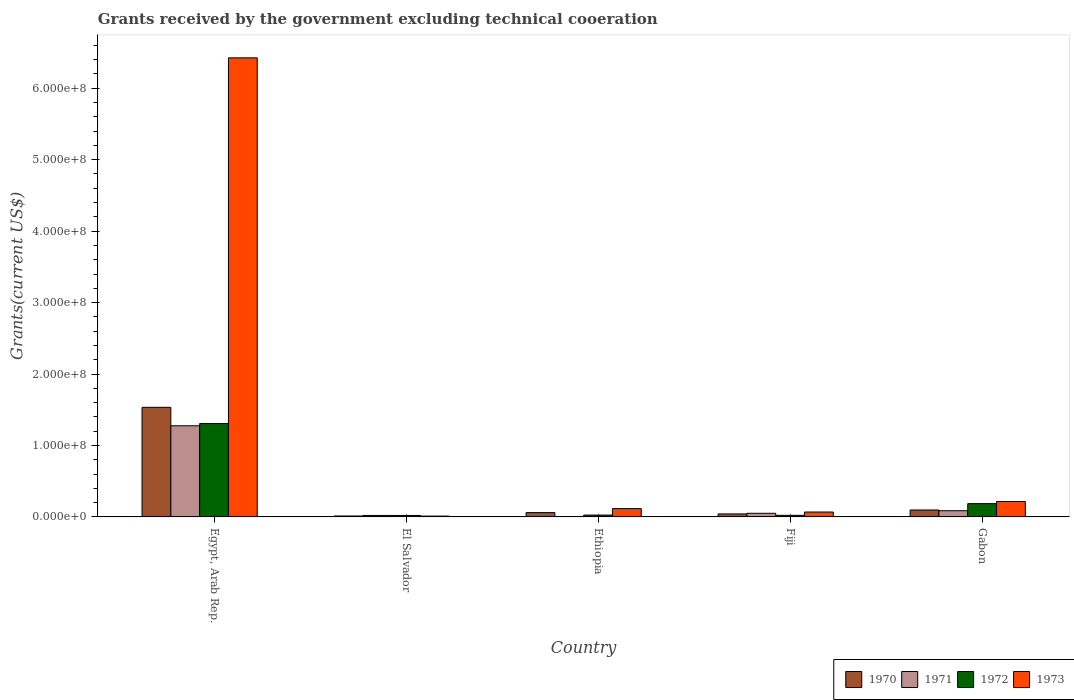How many different coloured bars are there?
Offer a very short reply. 4. How many bars are there on the 1st tick from the left?
Provide a succinct answer. 4. What is the label of the 4th group of bars from the left?
Your answer should be very brief. Fiji. What is the total grants received by the government in 1970 in Fiji?
Ensure brevity in your answer.  4.19e+06. Across all countries, what is the maximum total grants received by the government in 1972?
Keep it short and to the point. 1.31e+08. Across all countries, what is the minimum total grants received by the government in 1972?
Give a very brief answer. 2.07e+06. In which country was the total grants received by the government in 1973 maximum?
Keep it short and to the point. Egypt, Arab Rep. What is the total total grants received by the government in 1971 in the graph?
Your answer should be compact. 1.43e+08. What is the difference between the total grants received by the government in 1973 in Egypt, Arab Rep. and that in El Salvador?
Ensure brevity in your answer.  6.41e+08. What is the difference between the total grants received by the government in 1971 in Egypt, Arab Rep. and the total grants received by the government in 1973 in Fiji?
Provide a short and direct response. 1.21e+08. What is the average total grants received by the government in 1970 per country?
Offer a very short reply. 3.49e+07. What is the difference between the total grants received by the government of/in 1973 and total grants received by the government of/in 1970 in Fiji?
Give a very brief answer. 2.67e+06. In how many countries, is the total grants received by the government in 1971 greater than 500000000 US$?
Offer a terse response. 0. What is the ratio of the total grants received by the government in 1970 in Fiji to that in Gabon?
Offer a very short reply. 0.43. Is the total grants received by the government in 1970 in Ethiopia less than that in Gabon?
Provide a short and direct response. Yes. Is the difference between the total grants received by the government in 1973 in Egypt, Arab Rep. and El Salvador greater than the difference between the total grants received by the government in 1970 in Egypt, Arab Rep. and El Salvador?
Offer a terse response. Yes. What is the difference between the highest and the second highest total grants received by the government in 1971?
Provide a short and direct response. 1.19e+08. What is the difference between the highest and the lowest total grants received by the government in 1973?
Your answer should be compact. 6.41e+08. In how many countries, is the total grants received by the government in 1970 greater than the average total grants received by the government in 1970 taken over all countries?
Give a very brief answer. 1. Is the sum of the total grants received by the government in 1970 in Egypt, Arab Rep. and Gabon greater than the maximum total grants received by the government in 1973 across all countries?
Give a very brief answer. No. Is it the case that in every country, the sum of the total grants received by the government in 1972 and total grants received by the government in 1973 is greater than the sum of total grants received by the government in 1971 and total grants received by the government in 1970?
Provide a succinct answer. No. How many bars are there?
Your response must be concise. 19. Are all the bars in the graph horizontal?
Keep it short and to the point. No. Does the graph contain any zero values?
Provide a succinct answer. Yes. Does the graph contain grids?
Offer a very short reply. No. How are the legend labels stacked?
Your answer should be very brief. Horizontal. What is the title of the graph?
Offer a very short reply. Grants received by the government excluding technical cooeration. Does "2013" appear as one of the legend labels in the graph?
Offer a terse response. No. What is the label or title of the X-axis?
Provide a succinct answer. Country. What is the label or title of the Y-axis?
Provide a succinct answer. Grants(current US$). What is the Grants(current US$) in 1970 in Egypt, Arab Rep.?
Your answer should be compact. 1.53e+08. What is the Grants(current US$) of 1971 in Egypt, Arab Rep.?
Offer a very short reply. 1.28e+08. What is the Grants(current US$) in 1972 in Egypt, Arab Rep.?
Your answer should be compact. 1.31e+08. What is the Grants(current US$) in 1973 in Egypt, Arab Rep.?
Your answer should be very brief. 6.43e+08. What is the Grants(current US$) of 1970 in El Salvador?
Give a very brief answer. 1.32e+06. What is the Grants(current US$) in 1971 in El Salvador?
Your answer should be compact. 2.08e+06. What is the Grants(current US$) of 1972 in El Salvador?
Give a very brief answer. 2.07e+06. What is the Grants(current US$) of 1973 in El Salvador?
Your answer should be very brief. 1.15e+06. What is the Grants(current US$) of 1970 in Ethiopia?
Your answer should be compact. 6.05e+06. What is the Grants(current US$) in 1972 in Ethiopia?
Your answer should be very brief. 2.60e+06. What is the Grants(current US$) in 1973 in Ethiopia?
Ensure brevity in your answer.  1.16e+07. What is the Grants(current US$) of 1970 in Fiji?
Your answer should be compact. 4.19e+06. What is the Grants(current US$) of 1971 in Fiji?
Keep it short and to the point. 5.09e+06. What is the Grants(current US$) of 1972 in Fiji?
Ensure brevity in your answer.  2.23e+06. What is the Grants(current US$) of 1973 in Fiji?
Your answer should be compact. 6.86e+06. What is the Grants(current US$) in 1970 in Gabon?
Provide a succinct answer. 9.70e+06. What is the Grants(current US$) in 1971 in Gabon?
Make the answer very short. 8.68e+06. What is the Grants(current US$) in 1972 in Gabon?
Your answer should be compact. 1.86e+07. What is the Grants(current US$) of 1973 in Gabon?
Offer a very short reply. 2.16e+07. Across all countries, what is the maximum Grants(current US$) of 1970?
Ensure brevity in your answer.  1.53e+08. Across all countries, what is the maximum Grants(current US$) in 1971?
Ensure brevity in your answer.  1.28e+08. Across all countries, what is the maximum Grants(current US$) in 1972?
Keep it short and to the point. 1.31e+08. Across all countries, what is the maximum Grants(current US$) in 1973?
Provide a short and direct response. 6.43e+08. Across all countries, what is the minimum Grants(current US$) in 1970?
Keep it short and to the point. 1.32e+06. Across all countries, what is the minimum Grants(current US$) in 1971?
Provide a succinct answer. 0. Across all countries, what is the minimum Grants(current US$) of 1972?
Your response must be concise. 2.07e+06. Across all countries, what is the minimum Grants(current US$) in 1973?
Your answer should be compact. 1.15e+06. What is the total Grants(current US$) in 1970 in the graph?
Provide a short and direct response. 1.75e+08. What is the total Grants(current US$) in 1971 in the graph?
Your answer should be compact. 1.43e+08. What is the total Grants(current US$) of 1972 in the graph?
Keep it short and to the point. 1.56e+08. What is the total Grants(current US$) of 1973 in the graph?
Offer a very short reply. 6.84e+08. What is the difference between the Grants(current US$) of 1970 in Egypt, Arab Rep. and that in El Salvador?
Your answer should be compact. 1.52e+08. What is the difference between the Grants(current US$) of 1971 in Egypt, Arab Rep. and that in El Salvador?
Keep it short and to the point. 1.26e+08. What is the difference between the Grants(current US$) in 1972 in Egypt, Arab Rep. and that in El Salvador?
Provide a succinct answer. 1.29e+08. What is the difference between the Grants(current US$) in 1973 in Egypt, Arab Rep. and that in El Salvador?
Ensure brevity in your answer.  6.41e+08. What is the difference between the Grants(current US$) of 1970 in Egypt, Arab Rep. and that in Ethiopia?
Your answer should be very brief. 1.47e+08. What is the difference between the Grants(current US$) in 1972 in Egypt, Arab Rep. and that in Ethiopia?
Your response must be concise. 1.28e+08. What is the difference between the Grants(current US$) in 1973 in Egypt, Arab Rep. and that in Ethiopia?
Your answer should be compact. 6.31e+08. What is the difference between the Grants(current US$) in 1970 in Egypt, Arab Rep. and that in Fiji?
Your answer should be compact. 1.49e+08. What is the difference between the Grants(current US$) of 1971 in Egypt, Arab Rep. and that in Fiji?
Provide a succinct answer. 1.22e+08. What is the difference between the Grants(current US$) in 1972 in Egypt, Arab Rep. and that in Fiji?
Offer a very short reply. 1.28e+08. What is the difference between the Grants(current US$) of 1973 in Egypt, Arab Rep. and that in Fiji?
Make the answer very short. 6.36e+08. What is the difference between the Grants(current US$) of 1970 in Egypt, Arab Rep. and that in Gabon?
Give a very brief answer. 1.44e+08. What is the difference between the Grants(current US$) in 1971 in Egypt, Arab Rep. and that in Gabon?
Keep it short and to the point. 1.19e+08. What is the difference between the Grants(current US$) of 1972 in Egypt, Arab Rep. and that in Gabon?
Your response must be concise. 1.12e+08. What is the difference between the Grants(current US$) in 1973 in Egypt, Arab Rep. and that in Gabon?
Offer a very short reply. 6.21e+08. What is the difference between the Grants(current US$) of 1970 in El Salvador and that in Ethiopia?
Your answer should be very brief. -4.73e+06. What is the difference between the Grants(current US$) of 1972 in El Salvador and that in Ethiopia?
Ensure brevity in your answer.  -5.30e+05. What is the difference between the Grants(current US$) in 1973 in El Salvador and that in Ethiopia?
Provide a succinct answer. -1.05e+07. What is the difference between the Grants(current US$) in 1970 in El Salvador and that in Fiji?
Your answer should be very brief. -2.87e+06. What is the difference between the Grants(current US$) of 1971 in El Salvador and that in Fiji?
Ensure brevity in your answer.  -3.01e+06. What is the difference between the Grants(current US$) in 1972 in El Salvador and that in Fiji?
Your response must be concise. -1.60e+05. What is the difference between the Grants(current US$) in 1973 in El Salvador and that in Fiji?
Your response must be concise. -5.71e+06. What is the difference between the Grants(current US$) of 1970 in El Salvador and that in Gabon?
Ensure brevity in your answer.  -8.38e+06. What is the difference between the Grants(current US$) in 1971 in El Salvador and that in Gabon?
Ensure brevity in your answer.  -6.60e+06. What is the difference between the Grants(current US$) of 1972 in El Salvador and that in Gabon?
Your response must be concise. -1.66e+07. What is the difference between the Grants(current US$) in 1973 in El Salvador and that in Gabon?
Offer a terse response. -2.04e+07. What is the difference between the Grants(current US$) in 1970 in Ethiopia and that in Fiji?
Your answer should be compact. 1.86e+06. What is the difference between the Grants(current US$) in 1973 in Ethiopia and that in Fiji?
Your answer should be compact. 4.79e+06. What is the difference between the Grants(current US$) of 1970 in Ethiopia and that in Gabon?
Provide a succinct answer. -3.65e+06. What is the difference between the Grants(current US$) in 1972 in Ethiopia and that in Gabon?
Provide a short and direct response. -1.60e+07. What is the difference between the Grants(current US$) in 1973 in Ethiopia and that in Gabon?
Keep it short and to the point. -9.95e+06. What is the difference between the Grants(current US$) in 1970 in Fiji and that in Gabon?
Your response must be concise. -5.51e+06. What is the difference between the Grants(current US$) of 1971 in Fiji and that in Gabon?
Give a very brief answer. -3.59e+06. What is the difference between the Grants(current US$) in 1972 in Fiji and that in Gabon?
Make the answer very short. -1.64e+07. What is the difference between the Grants(current US$) in 1973 in Fiji and that in Gabon?
Ensure brevity in your answer.  -1.47e+07. What is the difference between the Grants(current US$) in 1970 in Egypt, Arab Rep. and the Grants(current US$) in 1971 in El Salvador?
Provide a short and direct response. 1.51e+08. What is the difference between the Grants(current US$) in 1970 in Egypt, Arab Rep. and the Grants(current US$) in 1972 in El Salvador?
Make the answer very short. 1.51e+08. What is the difference between the Grants(current US$) in 1970 in Egypt, Arab Rep. and the Grants(current US$) in 1973 in El Salvador?
Offer a very short reply. 1.52e+08. What is the difference between the Grants(current US$) in 1971 in Egypt, Arab Rep. and the Grants(current US$) in 1972 in El Salvador?
Give a very brief answer. 1.26e+08. What is the difference between the Grants(current US$) in 1971 in Egypt, Arab Rep. and the Grants(current US$) in 1973 in El Salvador?
Ensure brevity in your answer.  1.26e+08. What is the difference between the Grants(current US$) of 1972 in Egypt, Arab Rep. and the Grants(current US$) of 1973 in El Salvador?
Keep it short and to the point. 1.30e+08. What is the difference between the Grants(current US$) of 1970 in Egypt, Arab Rep. and the Grants(current US$) of 1972 in Ethiopia?
Your response must be concise. 1.51e+08. What is the difference between the Grants(current US$) of 1970 in Egypt, Arab Rep. and the Grants(current US$) of 1973 in Ethiopia?
Your response must be concise. 1.42e+08. What is the difference between the Grants(current US$) of 1971 in Egypt, Arab Rep. and the Grants(current US$) of 1972 in Ethiopia?
Your response must be concise. 1.25e+08. What is the difference between the Grants(current US$) of 1971 in Egypt, Arab Rep. and the Grants(current US$) of 1973 in Ethiopia?
Your answer should be compact. 1.16e+08. What is the difference between the Grants(current US$) in 1972 in Egypt, Arab Rep. and the Grants(current US$) in 1973 in Ethiopia?
Provide a short and direct response. 1.19e+08. What is the difference between the Grants(current US$) in 1970 in Egypt, Arab Rep. and the Grants(current US$) in 1971 in Fiji?
Make the answer very short. 1.48e+08. What is the difference between the Grants(current US$) in 1970 in Egypt, Arab Rep. and the Grants(current US$) in 1972 in Fiji?
Your answer should be very brief. 1.51e+08. What is the difference between the Grants(current US$) of 1970 in Egypt, Arab Rep. and the Grants(current US$) of 1973 in Fiji?
Your answer should be very brief. 1.47e+08. What is the difference between the Grants(current US$) of 1971 in Egypt, Arab Rep. and the Grants(current US$) of 1972 in Fiji?
Give a very brief answer. 1.25e+08. What is the difference between the Grants(current US$) of 1971 in Egypt, Arab Rep. and the Grants(current US$) of 1973 in Fiji?
Your response must be concise. 1.21e+08. What is the difference between the Grants(current US$) in 1972 in Egypt, Arab Rep. and the Grants(current US$) in 1973 in Fiji?
Give a very brief answer. 1.24e+08. What is the difference between the Grants(current US$) of 1970 in Egypt, Arab Rep. and the Grants(current US$) of 1971 in Gabon?
Your answer should be compact. 1.45e+08. What is the difference between the Grants(current US$) of 1970 in Egypt, Arab Rep. and the Grants(current US$) of 1972 in Gabon?
Ensure brevity in your answer.  1.35e+08. What is the difference between the Grants(current US$) in 1970 in Egypt, Arab Rep. and the Grants(current US$) in 1973 in Gabon?
Provide a succinct answer. 1.32e+08. What is the difference between the Grants(current US$) of 1971 in Egypt, Arab Rep. and the Grants(current US$) of 1972 in Gabon?
Offer a terse response. 1.09e+08. What is the difference between the Grants(current US$) in 1971 in Egypt, Arab Rep. and the Grants(current US$) in 1973 in Gabon?
Your response must be concise. 1.06e+08. What is the difference between the Grants(current US$) in 1972 in Egypt, Arab Rep. and the Grants(current US$) in 1973 in Gabon?
Your response must be concise. 1.09e+08. What is the difference between the Grants(current US$) of 1970 in El Salvador and the Grants(current US$) of 1972 in Ethiopia?
Your answer should be very brief. -1.28e+06. What is the difference between the Grants(current US$) of 1970 in El Salvador and the Grants(current US$) of 1973 in Ethiopia?
Make the answer very short. -1.03e+07. What is the difference between the Grants(current US$) of 1971 in El Salvador and the Grants(current US$) of 1972 in Ethiopia?
Ensure brevity in your answer.  -5.20e+05. What is the difference between the Grants(current US$) of 1971 in El Salvador and the Grants(current US$) of 1973 in Ethiopia?
Offer a terse response. -9.57e+06. What is the difference between the Grants(current US$) of 1972 in El Salvador and the Grants(current US$) of 1973 in Ethiopia?
Make the answer very short. -9.58e+06. What is the difference between the Grants(current US$) in 1970 in El Salvador and the Grants(current US$) in 1971 in Fiji?
Keep it short and to the point. -3.77e+06. What is the difference between the Grants(current US$) in 1970 in El Salvador and the Grants(current US$) in 1972 in Fiji?
Offer a very short reply. -9.10e+05. What is the difference between the Grants(current US$) of 1970 in El Salvador and the Grants(current US$) of 1973 in Fiji?
Your answer should be very brief. -5.54e+06. What is the difference between the Grants(current US$) of 1971 in El Salvador and the Grants(current US$) of 1973 in Fiji?
Your answer should be compact. -4.78e+06. What is the difference between the Grants(current US$) in 1972 in El Salvador and the Grants(current US$) in 1973 in Fiji?
Offer a terse response. -4.79e+06. What is the difference between the Grants(current US$) in 1970 in El Salvador and the Grants(current US$) in 1971 in Gabon?
Your answer should be compact. -7.36e+06. What is the difference between the Grants(current US$) of 1970 in El Salvador and the Grants(current US$) of 1972 in Gabon?
Ensure brevity in your answer.  -1.73e+07. What is the difference between the Grants(current US$) in 1970 in El Salvador and the Grants(current US$) in 1973 in Gabon?
Your response must be concise. -2.03e+07. What is the difference between the Grants(current US$) of 1971 in El Salvador and the Grants(current US$) of 1972 in Gabon?
Your answer should be compact. -1.65e+07. What is the difference between the Grants(current US$) in 1971 in El Salvador and the Grants(current US$) in 1973 in Gabon?
Make the answer very short. -1.95e+07. What is the difference between the Grants(current US$) in 1972 in El Salvador and the Grants(current US$) in 1973 in Gabon?
Ensure brevity in your answer.  -1.95e+07. What is the difference between the Grants(current US$) of 1970 in Ethiopia and the Grants(current US$) of 1971 in Fiji?
Your answer should be very brief. 9.60e+05. What is the difference between the Grants(current US$) in 1970 in Ethiopia and the Grants(current US$) in 1972 in Fiji?
Your response must be concise. 3.82e+06. What is the difference between the Grants(current US$) of 1970 in Ethiopia and the Grants(current US$) of 1973 in Fiji?
Your answer should be very brief. -8.10e+05. What is the difference between the Grants(current US$) of 1972 in Ethiopia and the Grants(current US$) of 1973 in Fiji?
Offer a very short reply. -4.26e+06. What is the difference between the Grants(current US$) in 1970 in Ethiopia and the Grants(current US$) in 1971 in Gabon?
Offer a very short reply. -2.63e+06. What is the difference between the Grants(current US$) of 1970 in Ethiopia and the Grants(current US$) of 1972 in Gabon?
Provide a short and direct response. -1.26e+07. What is the difference between the Grants(current US$) in 1970 in Ethiopia and the Grants(current US$) in 1973 in Gabon?
Keep it short and to the point. -1.56e+07. What is the difference between the Grants(current US$) of 1972 in Ethiopia and the Grants(current US$) of 1973 in Gabon?
Make the answer very short. -1.90e+07. What is the difference between the Grants(current US$) in 1970 in Fiji and the Grants(current US$) in 1971 in Gabon?
Your response must be concise. -4.49e+06. What is the difference between the Grants(current US$) in 1970 in Fiji and the Grants(current US$) in 1972 in Gabon?
Your answer should be very brief. -1.44e+07. What is the difference between the Grants(current US$) of 1970 in Fiji and the Grants(current US$) of 1973 in Gabon?
Provide a short and direct response. -1.74e+07. What is the difference between the Grants(current US$) in 1971 in Fiji and the Grants(current US$) in 1972 in Gabon?
Keep it short and to the point. -1.35e+07. What is the difference between the Grants(current US$) in 1971 in Fiji and the Grants(current US$) in 1973 in Gabon?
Give a very brief answer. -1.65e+07. What is the difference between the Grants(current US$) of 1972 in Fiji and the Grants(current US$) of 1973 in Gabon?
Your answer should be very brief. -1.94e+07. What is the average Grants(current US$) in 1970 per country?
Provide a succinct answer. 3.49e+07. What is the average Grants(current US$) of 1971 per country?
Make the answer very short. 2.87e+07. What is the average Grants(current US$) of 1972 per country?
Provide a short and direct response. 3.12e+07. What is the average Grants(current US$) in 1973 per country?
Offer a terse response. 1.37e+08. What is the difference between the Grants(current US$) of 1970 and Grants(current US$) of 1971 in Egypt, Arab Rep.?
Provide a short and direct response. 2.58e+07. What is the difference between the Grants(current US$) of 1970 and Grants(current US$) of 1972 in Egypt, Arab Rep.?
Offer a very short reply. 2.27e+07. What is the difference between the Grants(current US$) of 1970 and Grants(current US$) of 1973 in Egypt, Arab Rep.?
Offer a terse response. -4.89e+08. What is the difference between the Grants(current US$) of 1971 and Grants(current US$) of 1972 in Egypt, Arab Rep.?
Make the answer very short. -3.12e+06. What is the difference between the Grants(current US$) in 1971 and Grants(current US$) in 1973 in Egypt, Arab Rep.?
Your answer should be compact. -5.15e+08. What is the difference between the Grants(current US$) of 1972 and Grants(current US$) of 1973 in Egypt, Arab Rep.?
Offer a very short reply. -5.12e+08. What is the difference between the Grants(current US$) of 1970 and Grants(current US$) of 1971 in El Salvador?
Ensure brevity in your answer.  -7.60e+05. What is the difference between the Grants(current US$) of 1970 and Grants(current US$) of 1972 in El Salvador?
Offer a terse response. -7.50e+05. What is the difference between the Grants(current US$) of 1970 and Grants(current US$) of 1973 in El Salvador?
Keep it short and to the point. 1.70e+05. What is the difference between the Grants(current US$) in 1971 and Grants(current US$) in 1973 in El Salvador?
Offer a terse response. 9.30e+05. What is the difference between the Grants(current US$) of 1972 and Grants(current US$) of 1973 in El Salvador?
Give a very brief answer. 9.20e+05. What is the difference between the Grants(current US$) in 1970 and Grants(current US$) in 1972 in Ethiopia?
Your response must be concise. 3.45e+06. What is the difference between the Grants(current US$) of 1970 and Grants(current US$) of 1973 in Ethiopia?
Your answer should be compact. -5.60e+06. What is the difference between the Grants(current US$) of 1972 and Grants(current US$) of 1973 in Ethiopia?
Offer a very short reply. -9.05e+06. What is the difference between the Grants(current US$) of 1970 and Grants(current US$) of 1971 in Fiji?
Your response must be concise. -9.00e+05. What is the difference between the Grants(current US$) in 1970 and Grants(current US$) in 1972 in Fiji?
Offer a terse response. 1.96e+06. What is the difference between the Grants(current US$) of 1970 and Grants(current US$) of 1973 in Fiji?
Keep it short and to the point. -2.67e+06. What is the difference between the Grants(current US$) in 1971 and Grants(current US$) in 1972 in Fiji?
Your answer should be compact. 2.86e+06. What is the difference between the Grants(current US$) in 1971 and Grants(current US$) in 1973 in Fiji?
Give a very brief answer. -1.77e+06. What is the difference between the Grants(current US$) in 1972 and Grants(current US$) in 1973 in Fiji?
Provide a succinct answer. -4.63e+06. What is the difference between the Grants(current US$) of 1970 and Grants(current US$) of 1971 in Gabon?
Your answer should be compact. 1.02e+06. What is the difference between the Grants(current US$) in 1970 and Grants(current US$) in 1972 in Gabon?
Your response must be concise. -8.92e+06. What is the difference between the Grants(current US$) of 1970 and Grants(current US$) of 1973 in Gabon?
Offer a very short reply. -1.19e+07. What is the difference between the Grants(current US$) of 1971 and Grants(current US$) of 1972 in Gabon?
Offer a very short reply. -9.94e+06. What is the difference between the Grants(current US$) of 1971 and Grants(current US$) of 1973 in Gabon?
Provide a short and direct response. -1.29e+07. What is the difference between the Grants(current US$) of 1972 and Grants(current US$) of 1973 in Gabon?
Offer a very short reply. -2.98e+06. What is the ratio of the Grants(current US$) of 1970 in Egypt, Arab Rep. to that in El Salvador?
Offer a very short reply. 116.21. What is the ratio of the Grants(current US$) in 1971 in Egypt, Arab Rep. to that in El Salvador?
Provide a succinct answer. 61.34. What is the ratio of the Grants(current US$) of 1972 in Egypt, Arab Rep. to that in El Salvador?
Make the answer very short. 63.14. What is the ratio of the Grants(current US$) of 1973 in Egypt, Arab Rep. to that in El Salvador?
Your response must be concise. 558.74. What is the ratio of the Grants(current US$) in 1970 in Egypt, Arab Rep. to that in Ethiopia?
Offer a very short reply. 25.36. What is the ratio of the Grants(current US$) in 1972 in Egypt, Arab Rep. to that in Ethiopia?
Offer a terse response. 50.27. What is the ratio of the Grants(current US$) in 1973 in Egypt, Arab Rep. to that in Ethiopia?
Provide a short and direct response. 55.15. What is the ratio of the Grants(current US$) in 1970 in Egypt, Arab Rep. to that in Fiji?
Your response must be concise. 36.61. What is the ratio of the Grants(current US$) of 1971 in Egypt, Arab Rep. to that in Fiji?
Ensure brevity in your answer.  25.06. What is the ratio of the Grants(current US$) of 1972 in Egypt, Arab Rep. to that in Fiji?
Provide a succinct answer. 58.61. What is the ratio of the Grants(current US$) of 1973 in Egypt, Arab Rep. to that in Fiji?
Your response must be concise. 93.67. What is the ratio of the Grants(current US$) in 1970 in Egypt, Arab Rep. to that in Gabon?
Offer a terse response. 15.81. What is the ratio of the Grants(current US$) in 1971 in Egypt, Arab Rep. to that in Gabon?
Keep it short and to the point. 14.7. What is the ratio of the Grants(current US$) of 1972 in Egypt, Arab Rep. to that in Gabon?
Your answer should be very brief. 7.02. What is the ratio of the Grants(current US$) of 1973 in Egypt, Arab Rep. to that in Gabon?
Keep it short and to the point. 29.75. What is the ratio of the Grants(current US$) in 1970 in El Salvador to that in Ethiopia?
Offer a very short reply. 0.22. What is the ratio of the Grants(current US$) in 1972 in El Salvador to that in Ethiopia?
Offer a terse response. 0.8. What is the ratio of the Grants(current US$) of 1973 in El Salvador to that in Ethiopia?
Your answer should be very brief. 0.1. What is the ratio of the Grants(current US$) of 1970 in El Salvador to that in Fiji?
Make the answer very short. 0.32. What is the ratio of the Grants(current US$) of 1971 in El Salvador to that in Fiji?
Provide a short and direct response. 0.41. What is the ratio of the Grants(current US$) of 1972 in El Salvador to that in Fiji?
Your response must be concise. 0.93. What is the ratio of the Grants(current US$) in 1973 in El Salvador to that in Fiji?
Your response must be concise. 0.17. What is the ratio of the Grants(current US$) in 1970 in El Salvador to that in Gabon?
Provide a short and direct response. 0.14. What is the ratio of the Grants(current US$) in 1971 in El Salvador to that in Gabon?
Ensure brevity in your answer.  0.24. What is the ratio of the Grants(current US$) in 1972 in El Salvador to that in Gabon?
Your answer should be compact. 0.11. What is the ratio of the Grants(current US$) in 1973 in El Salvador to that in Gabon?
Ensure brevity in your answer.  0.05. What is the ratio of the Grants(current US$) of 1970 in Ethiopia to that in Fiji?
Your answer should be compact. 1.44. What is the ratio of the Grants(current US$) of 1972 in Ethiopia to that in Fiji?
Provide a short and direct response. 1.17. What is the ratio of the Grants(current US$) in 1973 in Ethiopia to that in Fiji?
Offer a terse response. 1.7. What is the ratio of the Grants(current US$) in 1970 in Ethiopia to that in Gabon?
Offer a terse response. 0.62. What is the ratio of the Grants(current US$) of 1972 in Ethiopia to that in Gabon?
Offer a very short reply. 0.14. What is the ratio of the Grants(current US$) in 1973 in Ethiopia to that in Gabon?
Your answer should be very brief. 0.54. What is the ratio of the Grants(current US$) of 1970 in Fiji to that in Gabon?
Your answer should be compact. 0.43. What is the ratio of the Grants(current US$) in 1971 in Fiji to that in Gabon?
Provide a succinct answer. 0.59. What is the ratio of the Grants(current US$) in 1972 in Fiji to that in Gabon?
Provide a short and direct response. 0.12. What is the ratio of the Grants(current US$) of 1973 in Fiji to that in Gabon?
Your answer should be very brief. 0.32. What is the difference between the highest and the second highest Grants(current US$) of 1970?
Offer a very short reply. 1.44e+08. What is the difference between the highest and the second highest Grants(current US$) in 1971?
Your response must be concise. 1.19e+08. What is the difference between the highest and the second highest Grants(current US$) in 1972?
Your response must be concise. 1.12e+08. What is the difference between the highest and the second highest Grants(current US$) of 1973?
Offer a very short reply. 6.21e+08. What is the difference between the highest and the lowest Grants(current US$) in 1970?
Offer a very short reply. 1.52e+08. What is the difference between the highest and the lowest Grants(current US$) in 1971?
Ensure brevity in your answer.  1.28e+08. What is the difference between the highest and the lowest Grants(current US$) in 1972?
Offer a very short reply. 1.29e+08. What is the difference between the highest and the lowest Grants(current US$) of 1973?
Offer a terse response. 6.41e+08. 